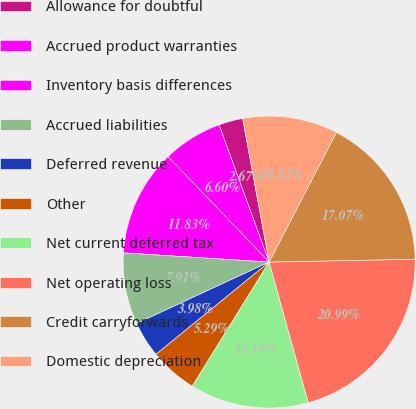Convert chart to OTSL. <chart><loc_0><loc_0><loc_500><loc_500><pie_chart><fcel>Allowance for doubtful<fcel>Accrued product warranties<fcel>Inventory basis differences<fcel>Accrued liabilities<fcel>Deferred revenue<fcel>Other<fcel>Net current deferred tax<fcel>Net operating loss<fcel>Credit carryforwards<fcel>Domestic depreciation<nl><fcel>2.67%<fcel>6.6%<fcel>11.83%<fcel>7.91%<fcel>3.98%<fcel>5.29%<fcel>13.14%<fcel>20.99%<fcel>17.07%<fcel>10.52%<nl></chart> 